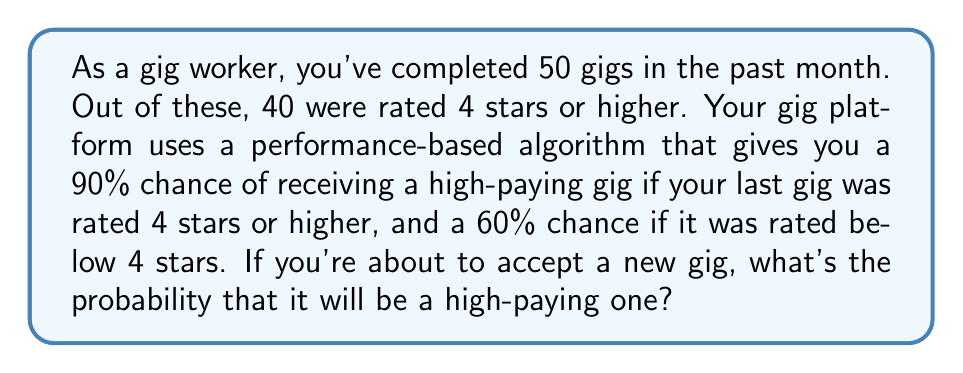What is the answer to this math problem? Let's approach this step-by-step:

1) First, we need to determine the probability of your last gig being rated 4 stars or higher. This is simply the proportion of high-rated gigs:

   $P(\text{High-rated}) = \frac{40}{50} = 0.8$ or 80%

2) Now, let's define our events:
   A: Getting a high-paying gig
   B: Last gig was high-rated

3) We're given:
   $P(A|B) = 0.9$ (probability of high-paying gig if last gig was high-rated)
   $P(A|\text{not }B) = 0.6$ (probability of high-paying gig if last gig was not high-rated)

4) We can use the law of total probability:

   $P(A) = P(A|B) \cdot P(B) + P(A|\text{not }B) \cdot P(\text{not }B)$

5) We know $P(B) = 0.8$ and $P(\text{not }B) = 1 - 0.8 = 0.2$

6) Substituting into the formula:

   $P(A) = 0.9 \cdot 0.8 + 0.6 \cdot 0.2$

7) Calculating:

   $P(A) = 0.72 + 0.12 = 0.84$

Therefore, the probability of receiving a high-paying gig is 0.84 or 84%.
Answer: 0.84 